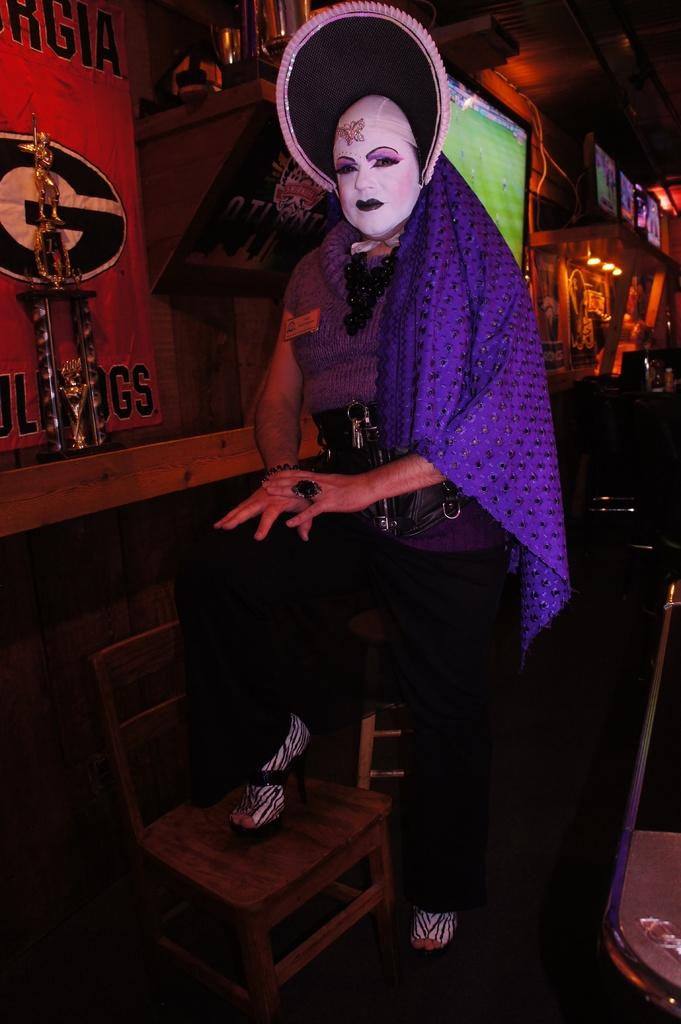What is the person in the image wearing? The person in the image is wearing a costume. What is on the floor in the image? There is a chair on the floor in the image. What is hanging on the wall in the image? There is a poster in the image. What is in the image that resembles a sculpture? There is a statue in the image. What can be seen in the background of the image? In the background of the image, there are screens, lights, and some objects visible. What type of crime is being committed in the image? There is no crime being committed in the image; it features a person in a costume, a chair, a poster, a statue, and various background elements. What type of camera is being used to capture the image? The question about the camera is irrelevant, as the conversation is focused on the content of the image itself, not the device used to capture it. 